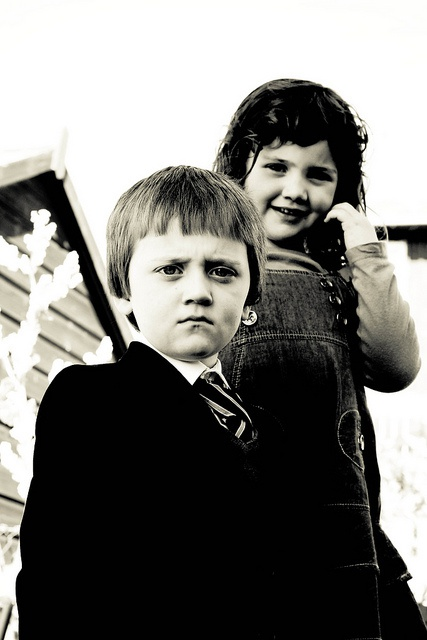Describe the objects in this image and their specific colors. I can see people in white, black, ivory, gray, and darkgray tones, people in white, black, gray, ivory, and darkgray tones, and tie in white, black, darkgray, gray, and lightgray tones in this image. 